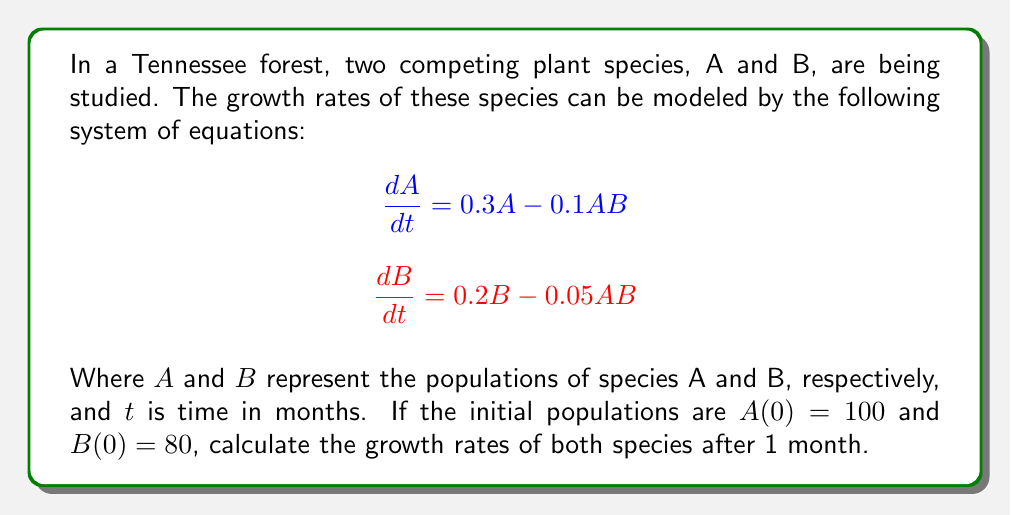Could you help me with this problem? To solve this problem, we need to follow these steps:

1. Understand the given equations:
   - $\frac{dA}{dt} = 0.3A - 0.1AB$ represents the growth rate of species A
   - $\frac{dB}{dt} = 0.2B - 0.05AB$ represents the growth rate of species B

2. Substitute the initial values:
   $A(0) = 100$ and $B(0) = 80$

3. Calculate the growth rate for species A:
   $$\frac{dA}{dt} = 0.3(100) - 0.1(100)(80)$$
   $$\frac{dA}{dt} = 30 - 800 = -770$$

4. Calculate the growth rate for species B:
   $$\frac{dB}{dt} = 0.2(80) - 0.05(100)(80)$$
   $$\frac{dB}{dt} = 16 - 400 = -384$$

5. Interpret the results:
   - The negative values indicate that both populations are decreasing after 1 month.
   - Species A is decreasing at a rate of 770 individuals per month.
   - Species B is decreasing at a rate of 384 individuals per month.

These growth rates represent the instantaneous rates of change at t = 0 (initial conditions). They provide information about the immediate dynamics of the two competing species in the Tennessee forest ecosystem.
Answer: After 1 month:
Growth rate of species A: $-770$ individuals per month
Growth rate of species B: $-384$ individuals per month 